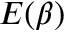<formula> <loc_0><loc_0><loc_500><loc_500>E ( \beta )</formula> 